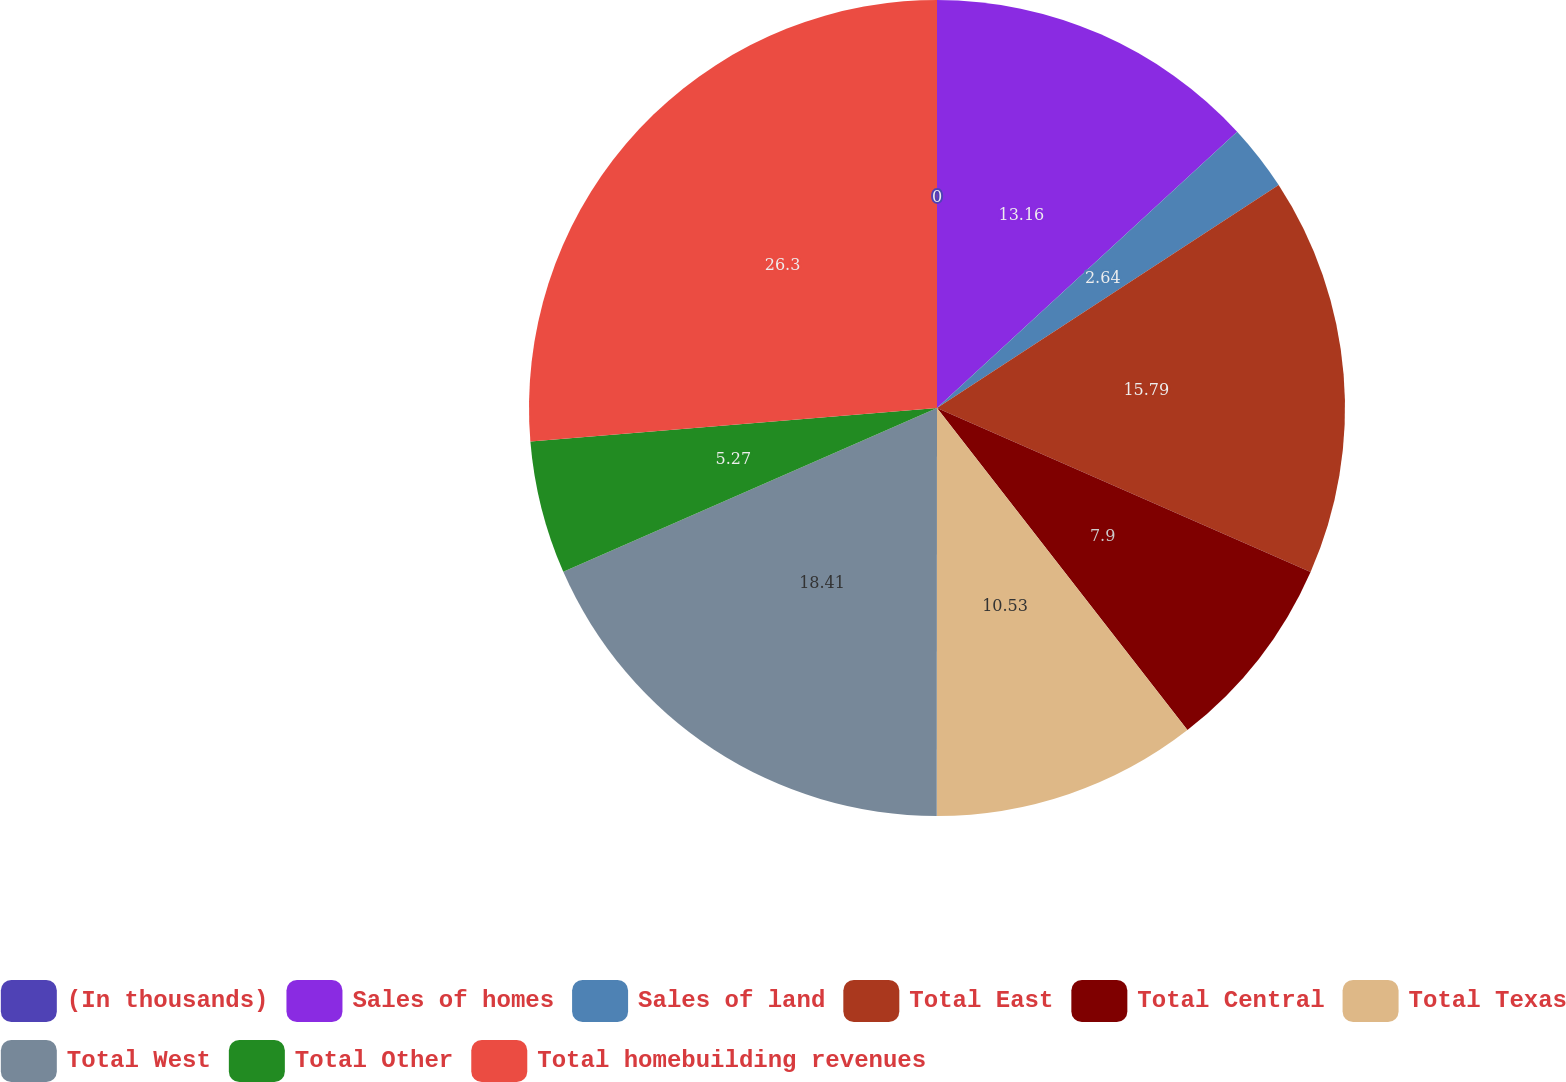<chart> <loc_0><loc_0><loc_500><loc_500><pie_chart><fcel>(In thousands)<fcel>Sales of homes<fcel>Sales of land<fcel>Total East<fcel>Total Central<fcel>Total Texas<fcel>Total West<fcel>Total Other<fcel>Total homebuilding revenues<nl><fcel>0.0%<fcel>13.16%<fcel>2.64%<fcel>15.79%<fcel>7.9%<fcel>10.53%<fcel>18.42%<fcel>5.27%<fcel>26.31%<nl></chart> 